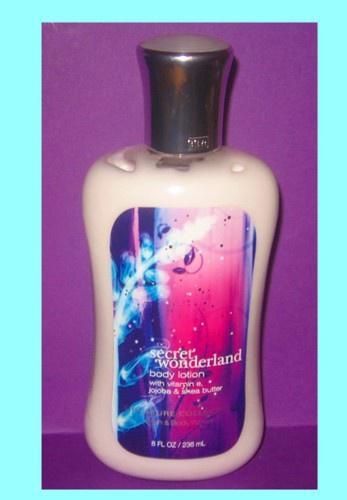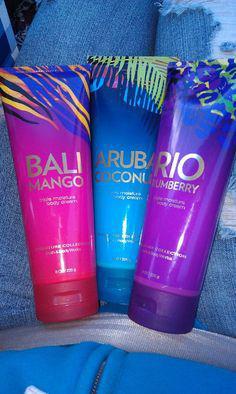The first image is the image on the left, the second image is the image on the right. Given the left and right images, does the statement "There are a total of 5 brightly colored self-tanning accessories laying in the sand." hold true? Answer yes or no. No. The first image is the image on the left, the second image is the image on the right. For the images shown, is this caption "bottles of lotion are displayed on a sandy surface" true? Answer yes or no. No. 